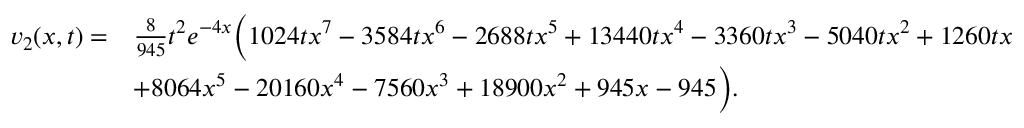<formula> <loc_0><loc_0><loc_500><loc_500>\begin{array} { r l } { v _ { 2 } ( x , t ) = } & { \frac { 8 } { 9 4 5 } t ^ { 2 } e ^ { - 4 x } \left ( 1 0 2 4 t x ^ { 7 } - 3 5 8 4 t x ^ { 6 } - 2 6 8 8 t x ^ { 5 } + 1 3 4 4 0 t x ^ { 4 } - 3 3 6 0 t x ^ { 3 } - 5 0 4 0 t x ^ { 2 } + 1 2 6 0 t x } \\ & { + 8 0 6 4 x ^ { 5 } - 2 0 1 6 0 x ^ { 4 } - 7 5 6 0 x ^ { 3 } + 1 8 9 0 0 x ^ { 2 } + 9 4 5 x - 9 4 5 \right ) . } \end{array}</formula> 